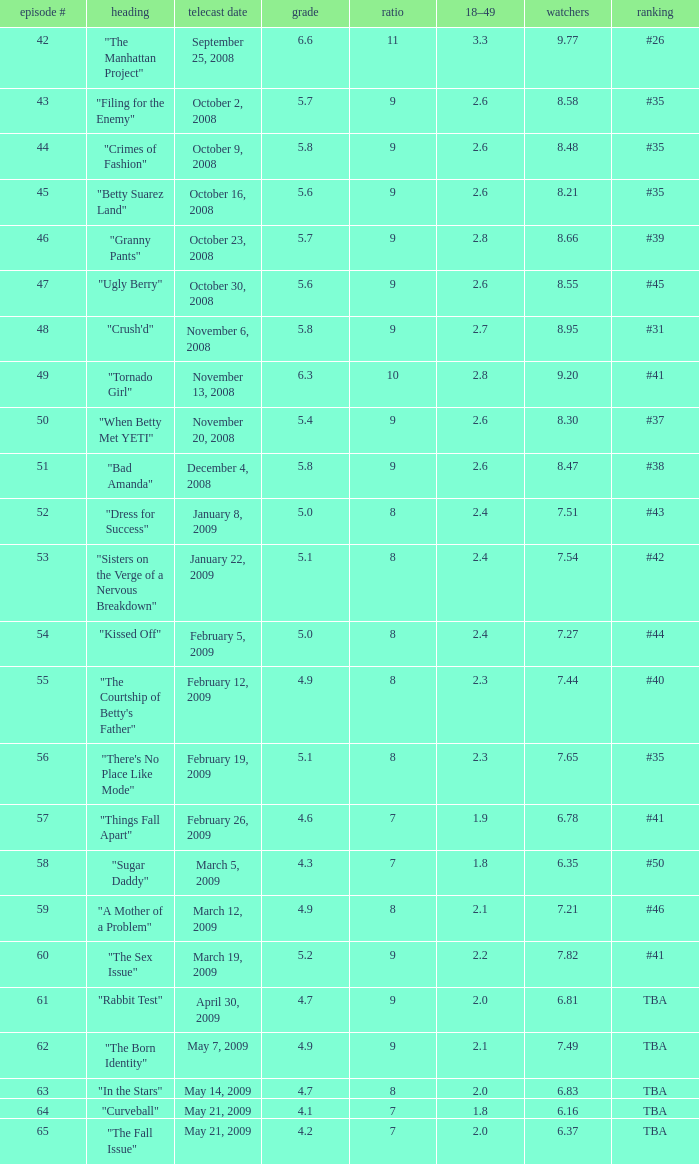What is the broadcast date with an 18-49 demographic larger than April 30, 2009, May 14, 2009, May 21, 2009. 